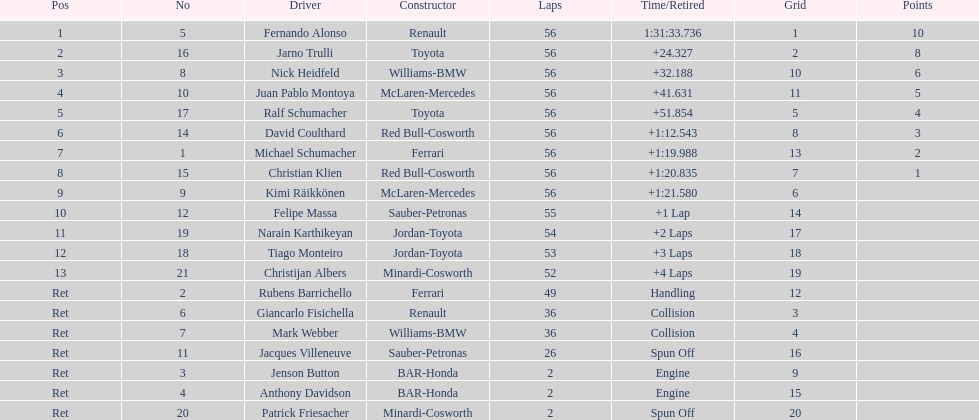How many drivers ended the race early because of engine problems? 2. 